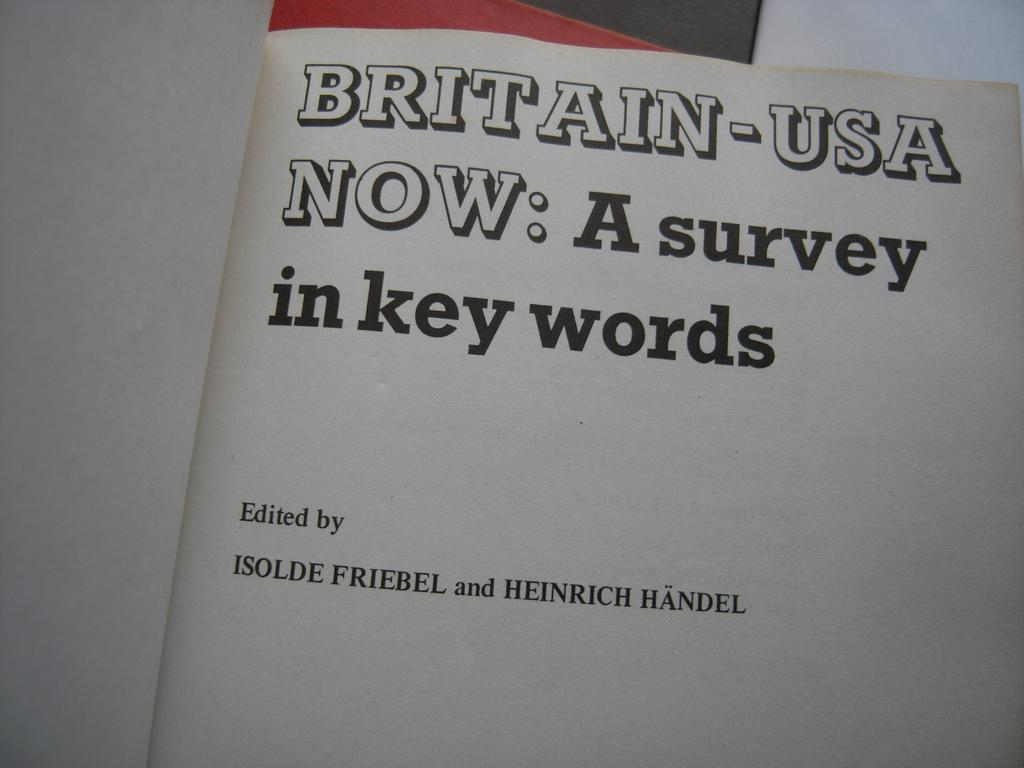<image>
Write a terse but informative summary of the picture. A book open to a page titled Britain-USA Now. 